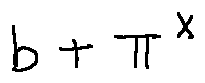Convert formula to latex. <formula><loc_0><loc_0><loc_500><loc_500>b + \pi ^ { X }</formula> 